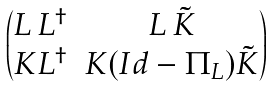Convert formula to latex. <formula><loc_0><loc_0><loc_500><loc_500>\begin{pmatrix} L \, L ^ { \dagger } & L \, \tilde { K } \\ K L ^ { \dagger } & K ( I d - \Pi _ { L } ) \tilde { K } \end{pmatrix}</formula> 